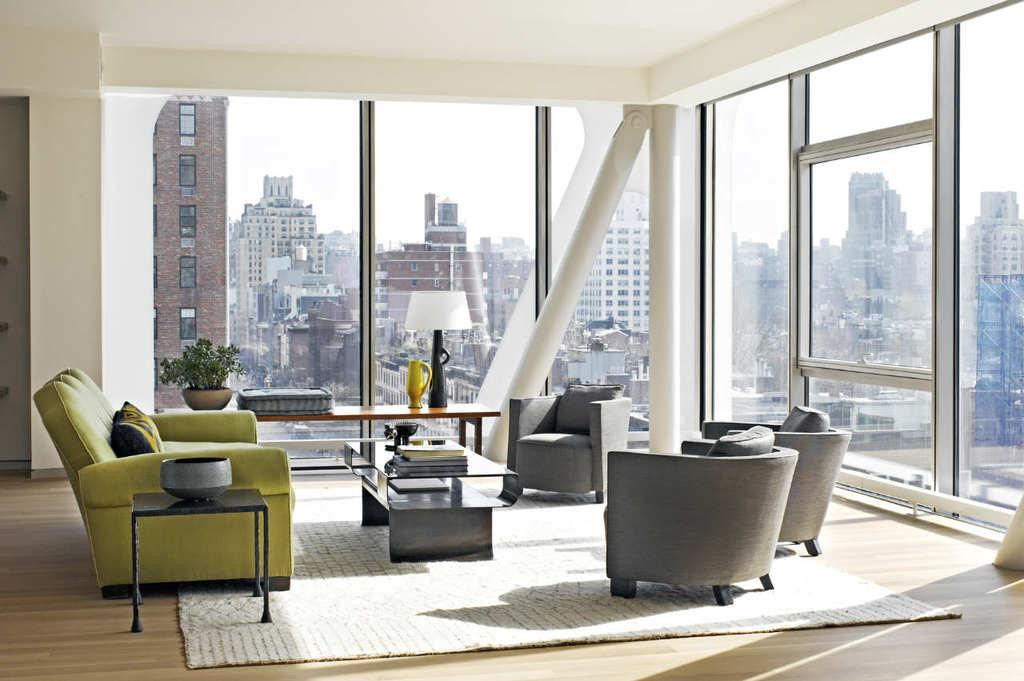What type of furniture is in the image? There is a sofa in the image. What other piece of furniture can be seen in the image? There is a table in the image. What is on top of the table? Books are present on the table. What architectural feature is visible in the image? There is a window in the image. What can be seen outside the window? There are buildings visible around the window. Reasoning: Let's think step by step by step in order to produce the conversation. We start by identifying the main pieces of furniture in the image, which are the sofa and table. Then, we expand the conversation to include the objects on the table, which are books. Next, we mention the window as an architectural feature and describe what can be seen outside the window, which are buildings. Absurd Question/Answer: What type of engine is visible in the image? There is no engine present in the image. What is the color of the eggnog being served on the sofa? There is no eggnog present in the image. 